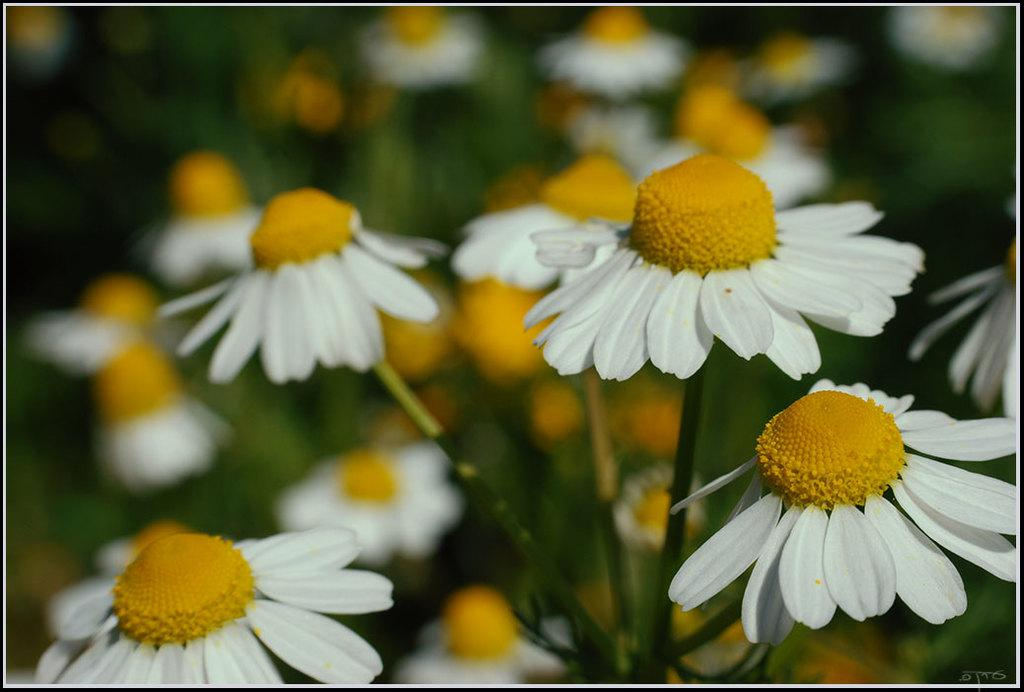What type of flowers are in the image? There are white sunflowers in the image. Where are the sunflowers located? The sunflowers are on plants. Can you describe the background of the image? The background of the image is blurred. What type of caption is written on the sunflowers in the image? There is no caption written on the sunflowers in the image. What type of cap can be seen on the plants in the image? There are no caps present on the plants in the image. 